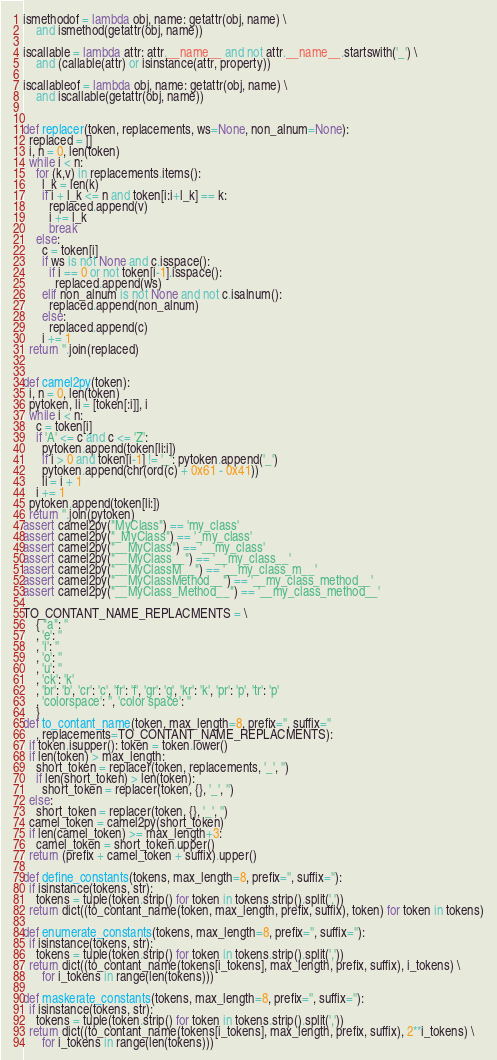<code> <loc_0><loc_0><loc_500><loc_500><_Python_>
ismethodof = lambda obj, name: getattr(obj, name) \
    and ismethod(getattr(obj, name))

iscallable = lambda attr: attr.__name__ and not attr.__name__.startswith('_') \
    and (callable(attr) or isinstance(attr, property))

iscallableof = lambda obj, name: getattr(obj, name) \
    and iscallable(getattr(obj, name))


def replacer(token, replacements, ws=None, non_alnum=None):
  replaced = []
  i, n = 0, len(token)
  while i < n:
    for (k,v) in replacements.items():
      l_k = len(k)
      if i + l_k <= n and token[i:i+l_k] == k:
        replaced.append(v)
        i += l_k
        break
    else:
      c = token[i]
      if ws is not None and c.isspace():
        if i == 0 or not token[i-1].isspace():
          replaced.append(ws)
      elif non_alnum is not None and not c.isalnum():
        replaced.append(non_alnum)
      else:
        replaced.append(c)
      i += 1
  return ''.join(replaced)


def camel2py(token):
  i, n = 0, len(token)
  pytoken, li = [token[:i]], i
  while i < n:
    c = token[i]
    if 'A' <= c and c <= 'Z':
      pytoken.append(token[li:i])
      if i > 0 and token[i-1] != '_': pytoken.append('_')
      pytoken.append(chr(ord(c) + 0x61 - 0x41))
      li = i + 1
    i += 1
  pytoken.append(token[li:])
  return ''.join(pytoken)
assert camel2py("MyClass") == 'my_class'
assert camel2py("_MyClass") == '_my_class'
assert camel2py("__MyClass") == '__my_class'
assert camel2py("__MyClass__") == '__my_class__'
assert camel2py("__MyClassM__") == '__my_class_m__'
assert camel2py("__MyClassMethod__") == '__my_class_method__'
assert camel2py("__MyClass_Method__") == '__my_class_method__'

TO_CONTANT_NAME_REPLACMENTS = \
    { "a": ''
    , 'e': ''
    , 'i': ''
    , 'o': ''
    , 'u': ''
    , 'ck': 'k'
    , 'br': 'b', 'cr': 'c', 'fr': 'f', 'gr': 'g', 'kr': 'k', 'pr': 'p', 'tr': 'p'
    , 'colorspace': '', 'color space': ''
    }
def to_contant_name(token, max_length=8, prefix='', suffix=''
    , replacements=TO_CONTANT_NAME_REPLACMENTS):
  if token.isupper(): token = token.lower()
  if len(token) > max_length:
    short_token = replacer(token, replacements, '_', '')
    if len(short_token) > len(token):
      short_token = replacer(token, {}, '_', '')
  else:
    short_token = replacer(token, {}, '_', '')
  camel_token = camel2py(short_token)
  if len(camel_token) >= max_length+3:
    camel_token = short_token.upper()
  return (prefix + camel_token + suffix).upper()

def define_constants(tokens, max_length=8, prefix='', suffix=''):
  if isinstance(tokens, str):
    tokens = tuple(token.strip() for token in tokens.strip().split(','))
  return dict((to_contant_name(token, max_length, prefix, suffix), token) for token in tokens)

def enumerate_constants(tokens, max_length=8, prefix='', suffix=''):
  if isinstance(tokens, str):
    tokens = tuple(token.strip() for token in tokens.strip().split(','))
  return dict((to_contant_name(tokens[i_tokens], max_length, prefix, suffix), i_tokens) \
      for i_tokens in range(len(tokens)))

def maskerate_constants(tokens, max_length=8, prefix='', suffix=''):
  if isinstance(tokens, str):
    tokens = tuple(token.strip() for token in tokens.strip().split(','))
  return dict((to_contant_name(tokens[i_tokens], max_length, prefix, suffix), 2**i_tokens) \
      for i_tokens in range(len(tokens)))


</code> 